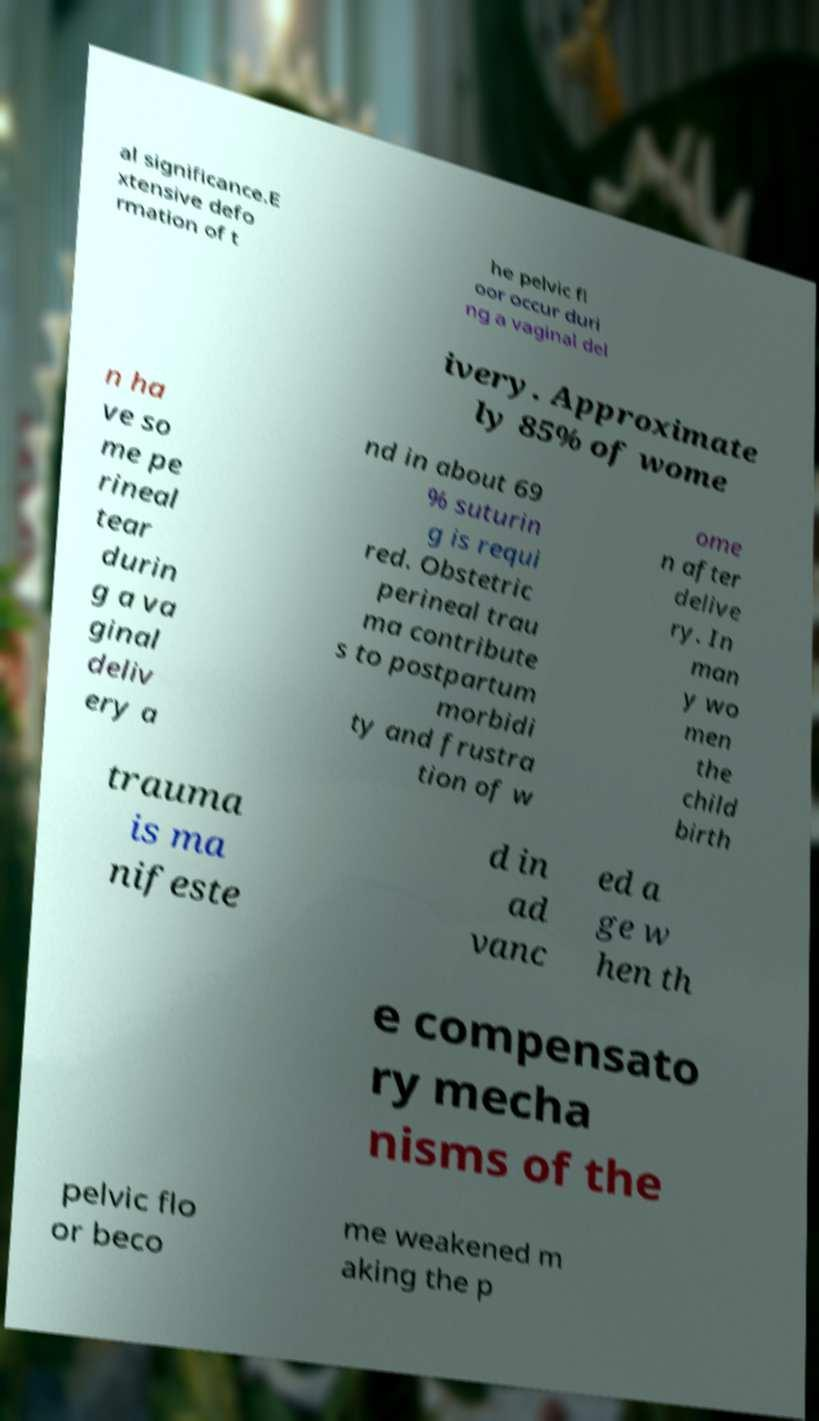There's text embedded in this image that I need extracted. Can you transcribe it verbatim? al significance.E xtensive defo rmation of t he pelvic fl oor occur duri ng a vaginal del ivery. Approximate ly 85% of wome n ha ve so me pe rineal tear durin g a va ginal deliv ery a nd in about 69 % suturin g is requi red. Obstetric perineal trau ma contribute s to postpartum morbidi ty and frustra tion of w ome n after delive ry. In man y wo men the child birth trauma is ma nifeste d in ad vanc ed a ge w hen th e compensato ry mecha nisms of the pelvic flo or beco me weakened m aking the p 